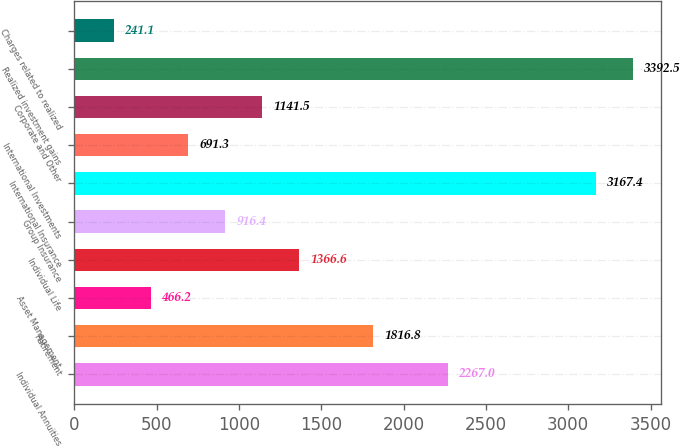Convert chart. <chart><loc_0><loc_0><loc_500><loc_500><bar_chart><fcel>Individual Annuities<fcel>Retirement<fcel>Asset Management<fcel>Individual Life<fcel>Group Insurance<fcel>International Insurance<fcel>International Investments<fcel>Corporate and Other<fcel>Realized investment gains<fcel>Charges related to realized<nl><fcel>2267<fcel>1816.8<fcel>466.2<fcel>1366.6<fcel>916.4<fcel>3167.4<fcel>691.3<fcel>1141.5<fcel>3392.5<fcel>241.1<nl></chart> 